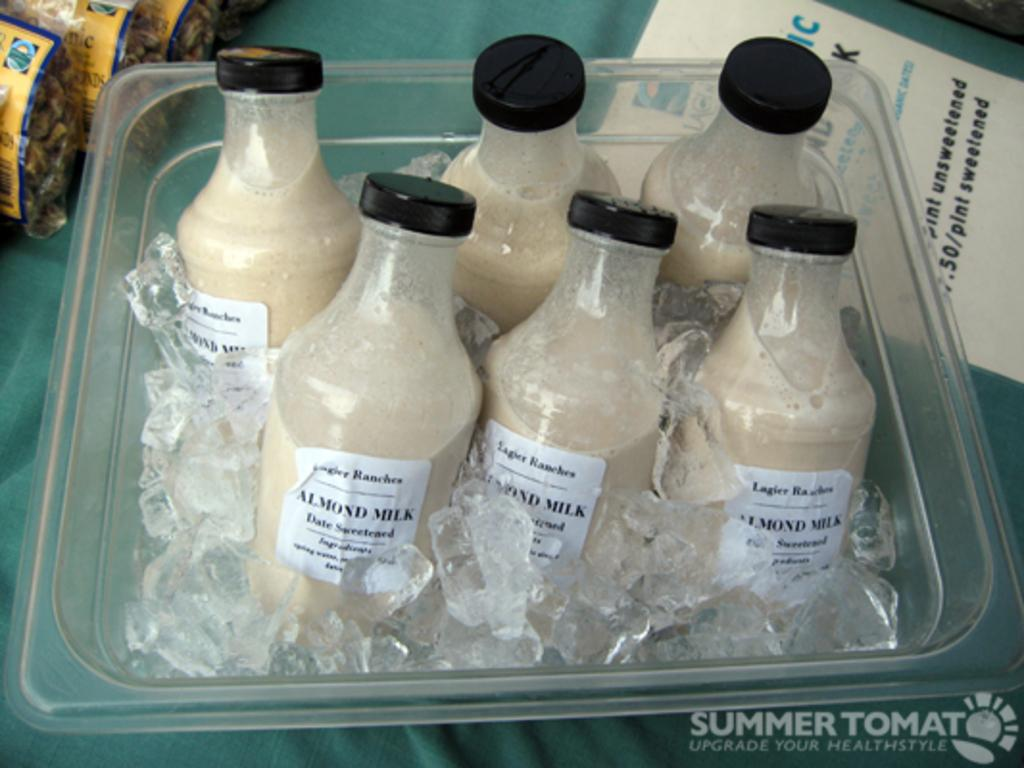Provide a one-sentence caption for the provided image. Six small bottles of almond milk sit in a container full of ice. 